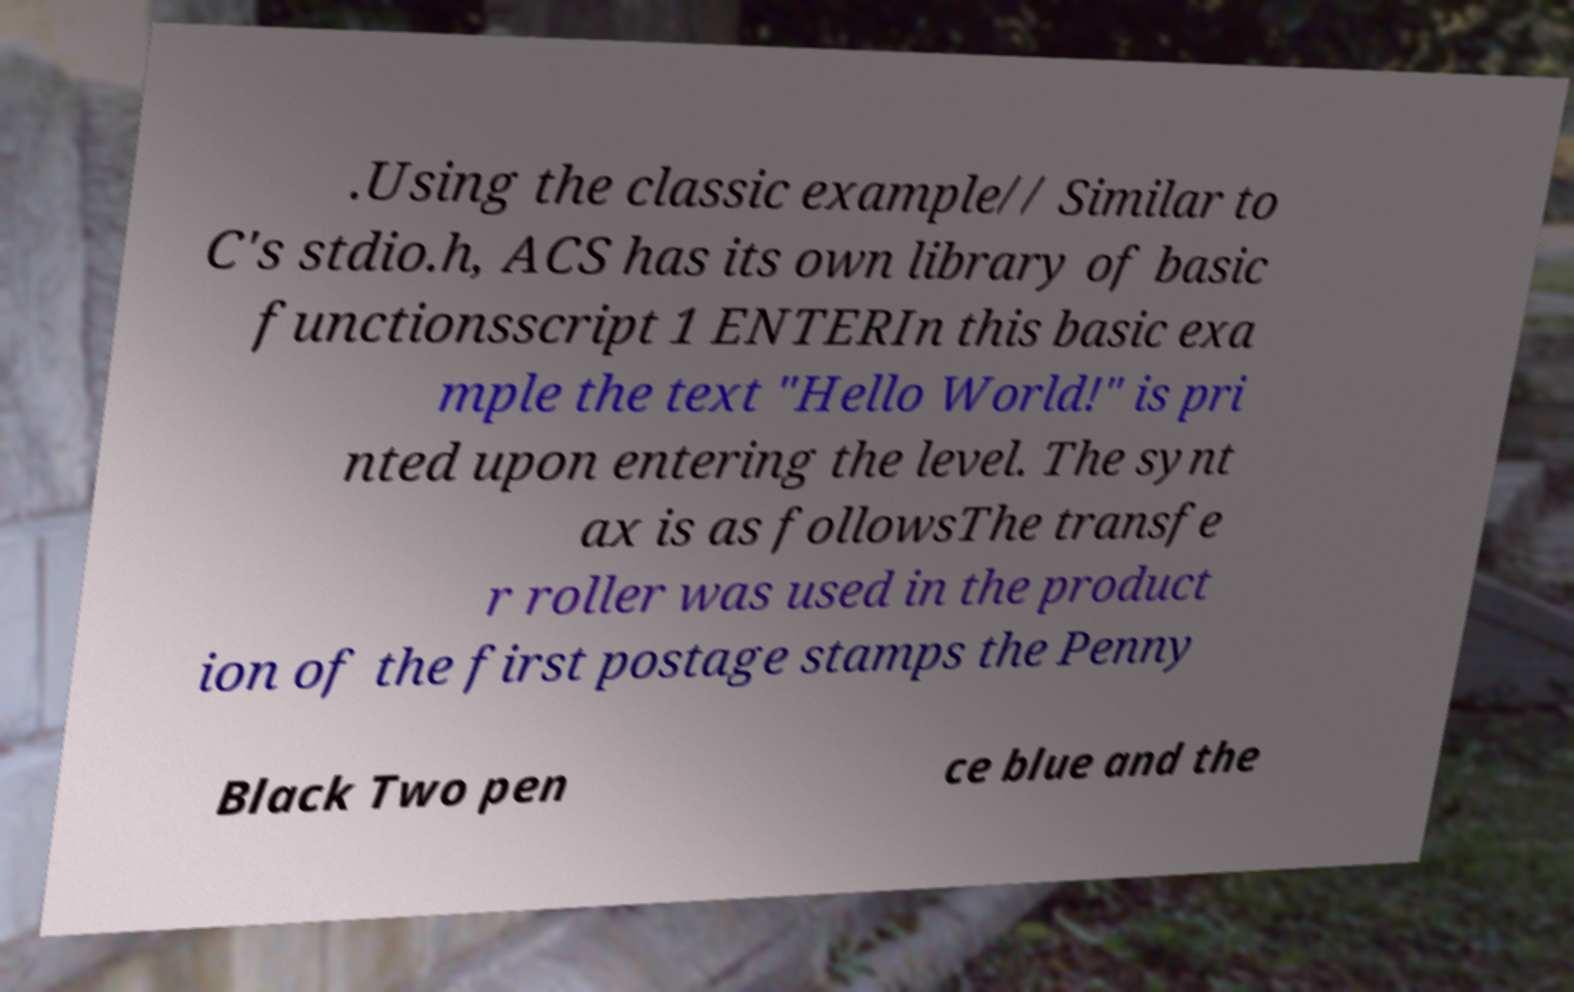Please identify and transcribe the text found in this image. .Using the classic example// Similar to C's stdio.h, ACS has its own library of basic functionsscript 1 ENTERIn this basic exa mple the text "Hello World!" is pri nted upon entering the level. The synt ax is as followsThe transfe r roller was used in the product ion of the first postage stamps the Penny Black Two pen ce blue and the 